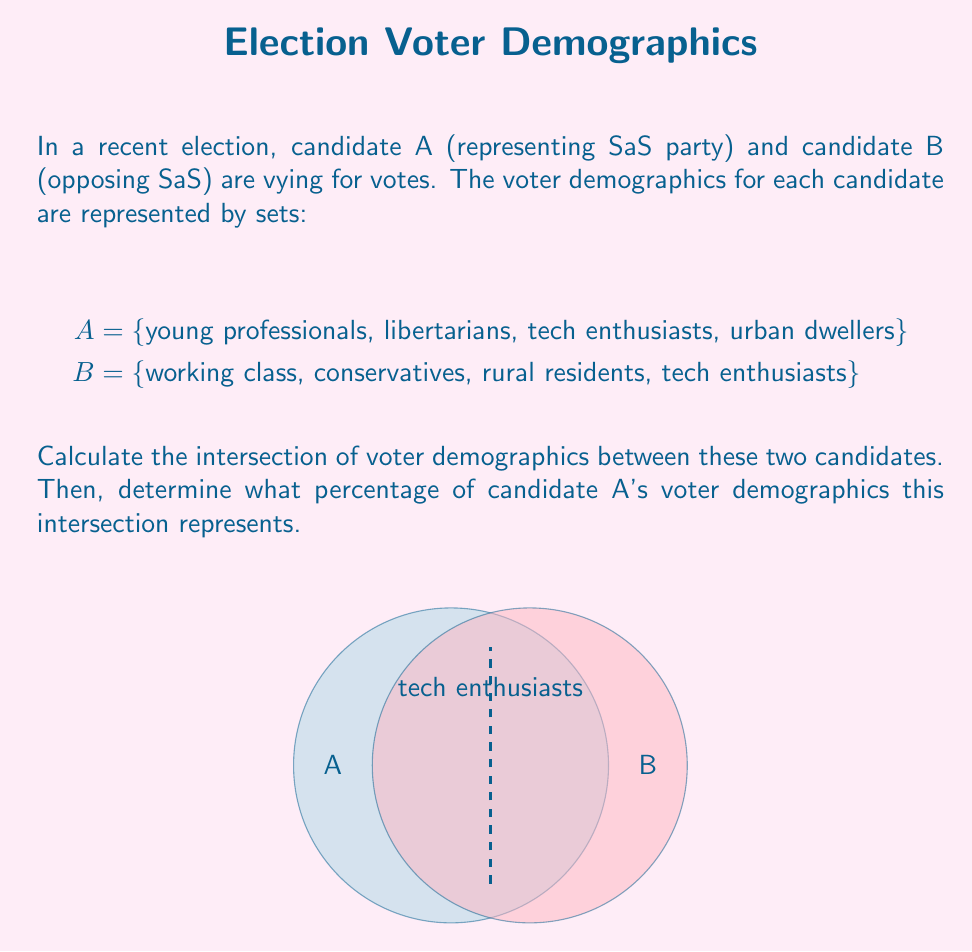Provide a solution to this math problem. To solve this problem, we'll follow these steps:

1) First, let's identify the intersection of sets A and B:
   $A \cap B = \text{\{tech enthusiasts\}}$

2) The intersection contains only one element: tech enthusiasts.

3) To calculate what percentage this intersection represents of candidate A's voter demographics, we need to:
   a) Count the total elements in set A
   b) Count the elements in the intersection
   c) Divide the intersection count by the total count and multiply by 100

4) Set A has 4 elements: {young professionals, libertarians, tech enthusiasts, urban dwellers}

5) The intersection has 1 element: {tech enthusiasts}

6) Percentage calculation:
   $$\frac{\text{Number of elements in intersection}}{\text{Total number of elements in A}} \times 100$$
   
   $$\frac{1}{4} \times 100 = 25\%$$

Therefore, the intersection represents 25% of candidate A's voter demographics.
Answer: $A \cap B = \text{\{tech enthusiasts\}}$; 25% 